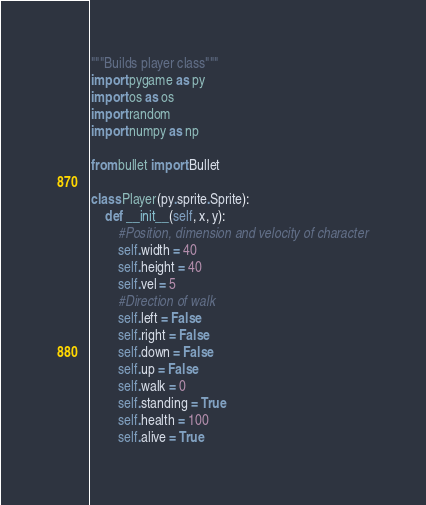Convert code to text. <code><loc_0><loc_0><loc_500><loc_500><_Python_>"""Builds player class"""
import pygame as py
import os as os
import random
import numpy as np

from bullet import Bullet

class Player(py.sprite.Sprite):
    def __init__(self, x, y):       
        #Position, dimension and velocity of character
        self.width = 40
        self.height = 40
        self.vel = 5
        #Direction of walk
        self.left = False
        self.right = False
        self.down = False
        self.up = False
        self.walk = 0
        self.standing = True
        self.health = 100
        self.alive = True</code> 